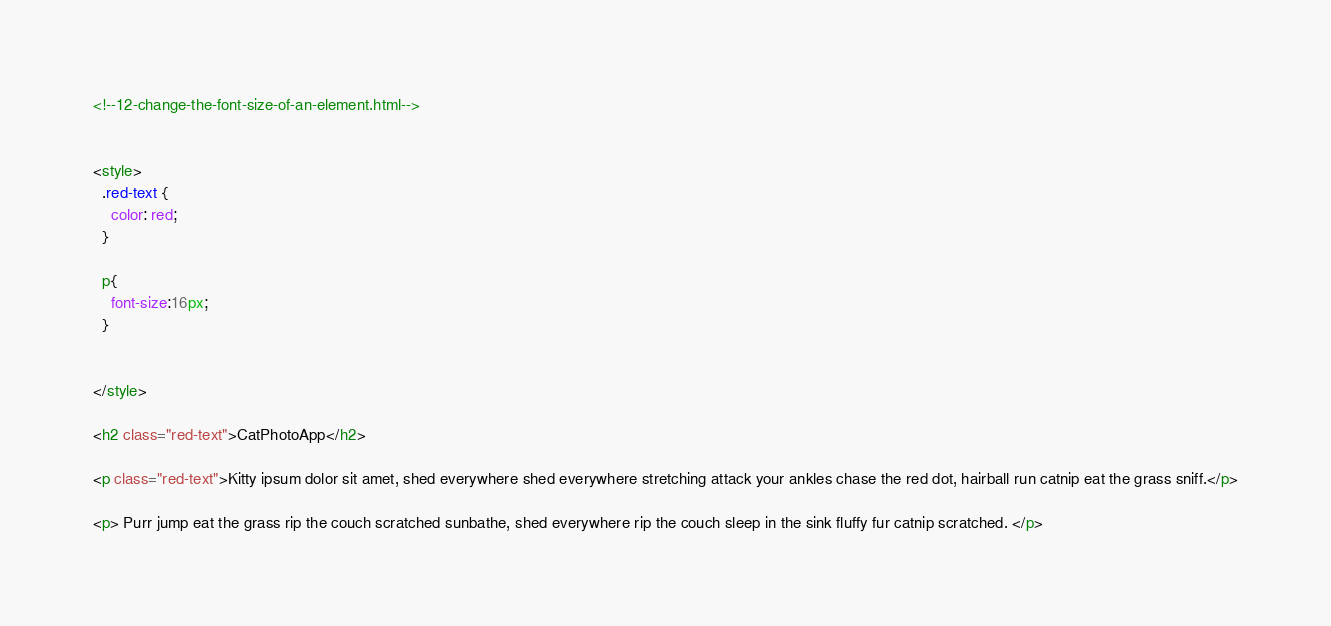<code> <loc_0><loc_0><loc_500><loc_500><_HTML_><!--12-change-the-font-size-of-an-element.html-->


<style>
  .red-text {
    color: red;
  }
  
  p{
    font-size:16px;
  }
  
  
</style>

<h2 class="red-text">CatPhotoApp</h2>

<p class="red-text">Kitty ipsum dolor sit amet, shed everywhere shed everywhere stretching attack your ankles chase the red dot, hairball run catnip eat the grass sniff.</p>

<p> Purr jump eat the grass rip the couch scratched sunbathe, shed everywhere rip the couch sleep in the sink fluffy fur catnip scratched. </p>

</code> 